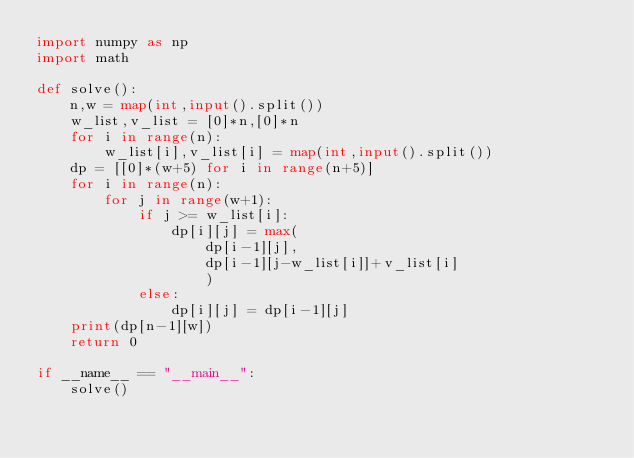Convert code to text. <code><loc_0><loc_0><loc_500><loc_500><_Python_>import numpy as np
import math

def solve():
    n,w = map(int,input().split())
    w_list,v_list = [0]*n,[0]*n
    for i in range(n):
        w_list[i],v_list[i] = map(int,input().split())
    dp = [[0]*(w+5) for i in range(n+5)]
    for i in range(n):
        for j in range(w+1):
            if j >= w_list[i]:
                dp[i][j] = max(
                    dp[i-1][j],
                    dp[i-1][j-w_list[i]]+v_list[i]
                    )
            else:
                dp[i][j] = dp[i-1][j]
    print(dp[n-1][w])
    return 0

if __name__ == "__main__":
    solve()
</code> 